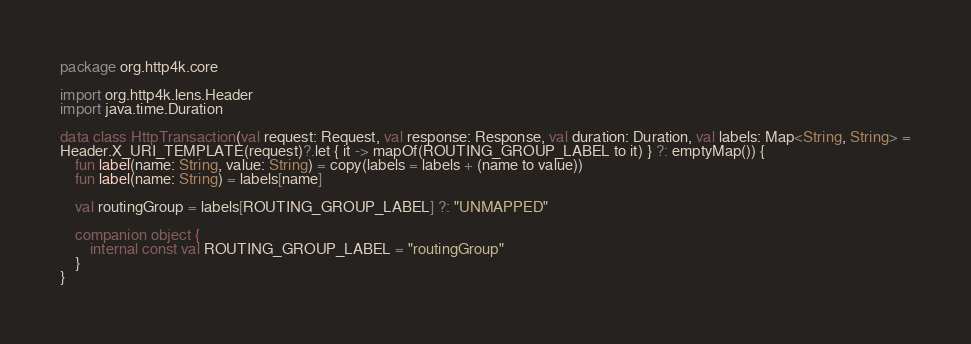Convert code to text. <code><loc_0><loc_0><loc_500><loc_500><_Kotlin_>package org.http4k.core

import org.http4k.lens.Header
import java.time.Duration

data class HttpTransaction(val request: Request, val response: Response, val duration: Duration, val labels: Map<String, String> =
Header.X_URI_TEMPLATE(request)?.let { it -> mapOf(ROUTING_GROUP_LABEL to it) } ?: emptyMap()) {
    fun label(name: String, value: String) = copy(labels = labels + (name to value))
    fun label(name: String) = labels[name]

    val routingGroup = labels[ROUTING_GROUP_LABEL] ?: "UNMAPPED"

    companion object {
        internal const val ROUTING_GROUP_LABEL = "routingGroup"
    }
}</code> 